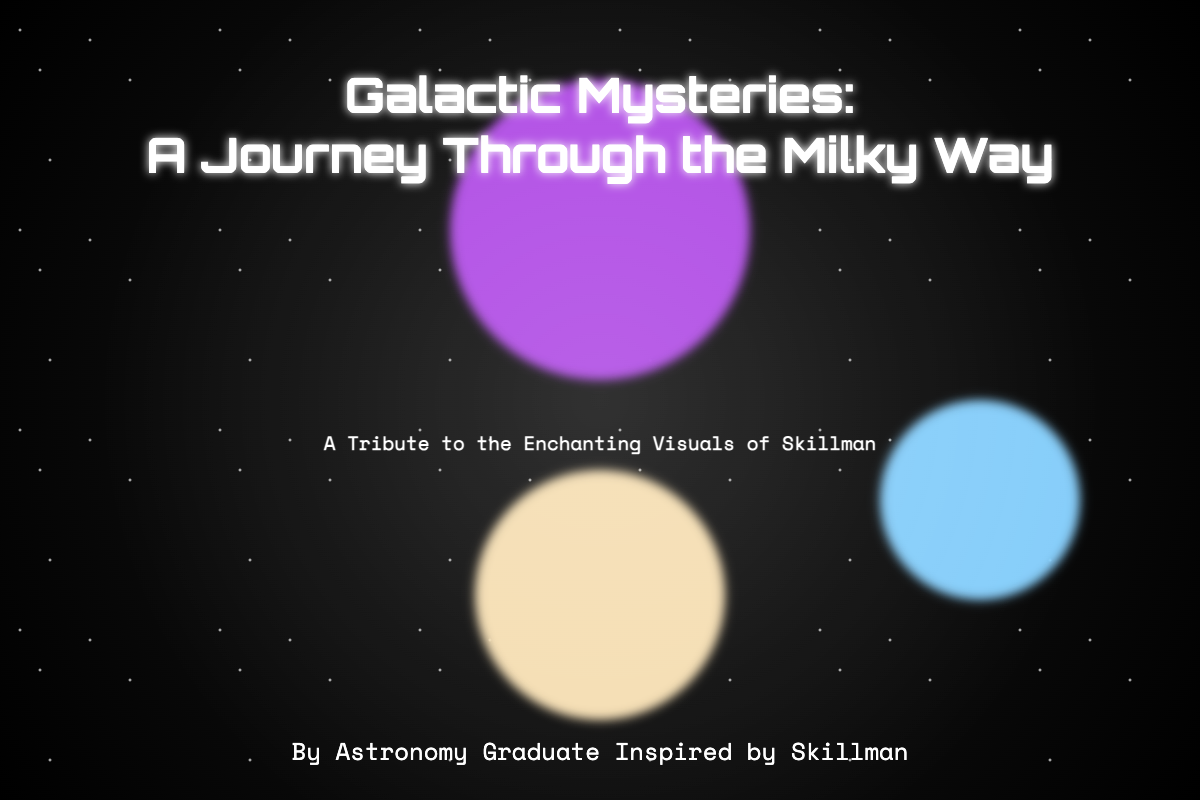What is the title of the book? The title of the book is prominently displayed near the center of the cover and is "Galactic Mysteries: A Journey Through the Milky Way."
Answer: Galactic Mysteries: A Journey Through the Milky Way Who is the author of the book? The author is mentioned at the bottom of the cover and is described as "By Astronomy Graduate Inspired by Skillman."
Answer: By Astronomy Graduate Inspired by Skillman What visual element is depicted at the top of the cover? A nebula is represented at the top of the cover, adding a colorful and cosmic visual aspect to the design.
Answer: Nebula What colors are used for the galactic center element? The galactic center features a background color described as "f5deb3."
Answer: f5deb3 What is emphasized in the subtitle? The subtitle emphasizes a tribute and appreciation for the visuals associated with the artist Skillman.
Answer: A Tribute to the Enchanting Visuals of Skillman How many distinct visual elements are used in the book cover design? The cover design features three distinct visual elements: nebula, star cluster, and galactic center.
Answer: Three What is the purpose of the "ethereal glow" on the cover? The ethereal glow serves to enhance the cosmic and mystical theme of the book cover by providing a soft, radiant background.
Answer: To enhance the cosmic theme What type of gradient is used for the background? The background employs a radial gradient that transitions from dark colors to highlight the celestial theme of the cover.
Answer: Radial gradient 